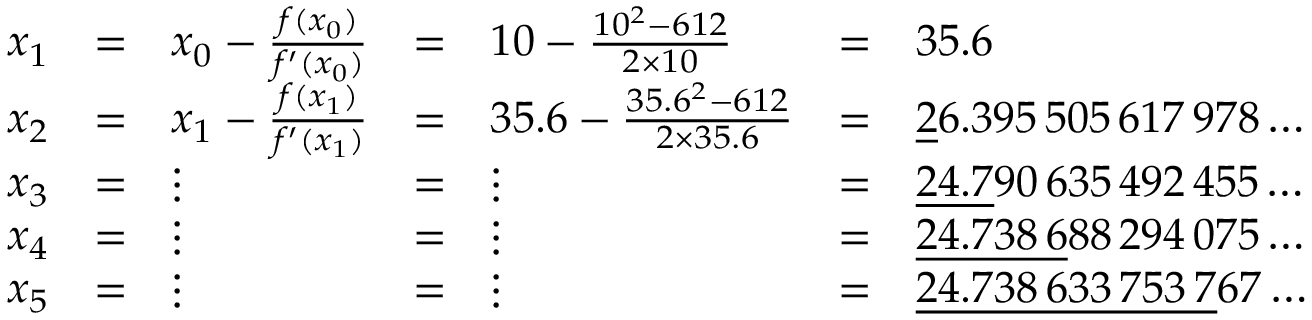Convert formula to latex. <formula><loc_0><loc_0><loc_500><loc_500>{ \begin{array} { l l l l l l l } { x _ { 1 } } & { = } & { x _ { 0 } - { \frac { f ( x _ { 0 } ) } { f ^ { \prime } ( x _ { 0 } ) } } } & { = } & { 1 0 - { \frac { 1 0 ^ { 2 } - 6 1 2 } { 2 \times 1 0 } } } & { = } & { 3 5 . 6 \quad \, } \\ { x _ { 2 } } & { = } & { x _ { 1 } - { \frac { f ( x _ { 1 } ) } { f ^ { \prime } ( x _ { 1 } ) } } } & { = } & { 3 5 . 6 - { \frac { 3 5 . 6 ^ { 2 } - 6 1 2 } { 2 \times 3 5 . 6 } } } & { = } & { { \underline { 2 } } 6 . 3 9 5 \, 5 0 5 \, 6 1 7 \, 9 7 8 \dots } \\ { x _ { 3 } } & { = } & { \vdots } & { = } & { \vdots } & { = } & { { \underline { 2 4 . 7 } } 9 0 \, 6 3 5 \, 4 9 2 \, 4 5 5 \dots } \\ { x _ { 4 } } & { = } & { \vdots } & { = } & { \vdots } & { = } & { { \underline { 2 4 . 7 3 8 \, 6 } } 8 8 \, 2 9 4 \, 0 7 5 \dots } \\ { x _ { 5 } } & { = } & { \vdots } & { = } & { \vdots } & { = } & { { \underline { 2 4 . 7 3 8 \, 6 3 3 \, 7 5 3 \, 7 } } 6 7 \dots } \end{array} }</formula> 